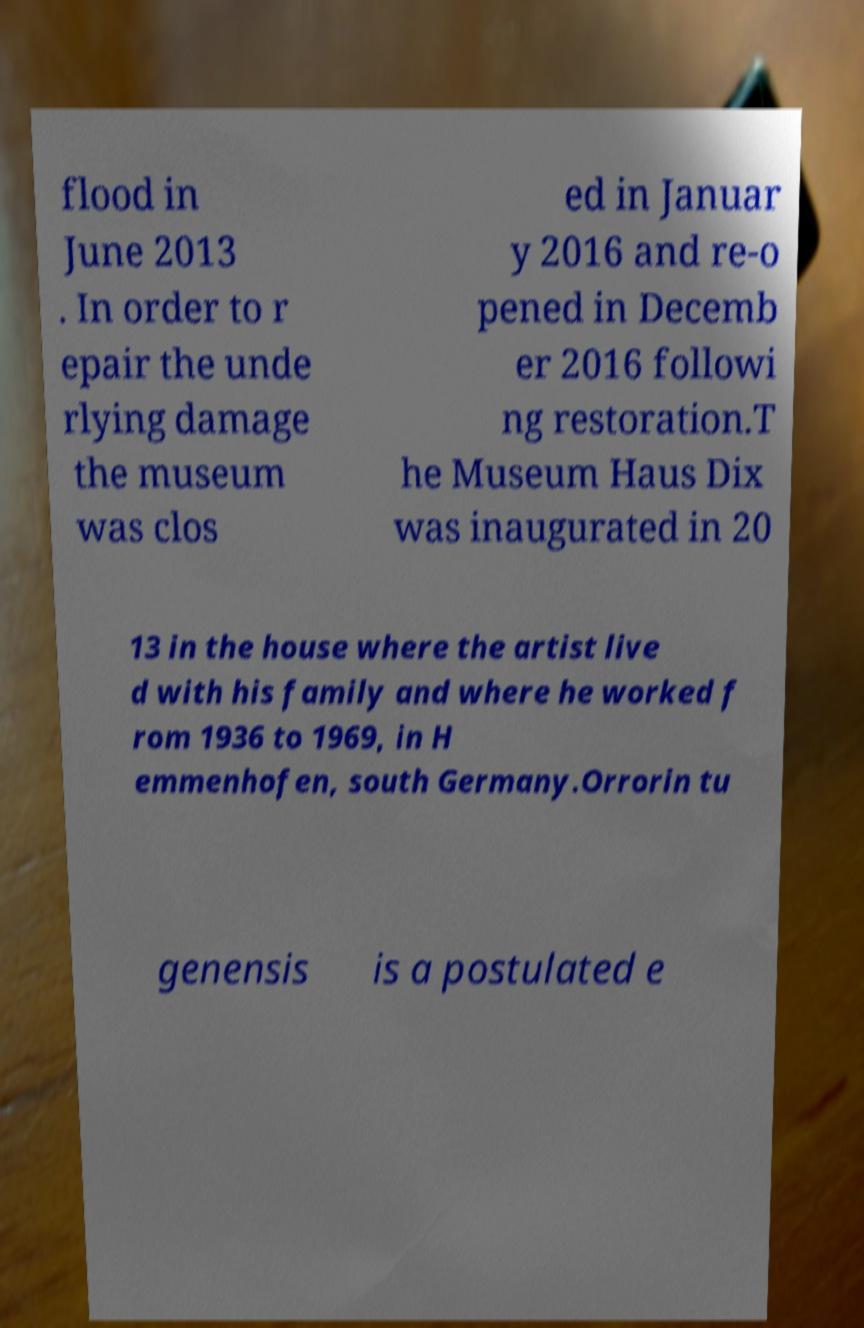Can you read and provide the text displayed in the image?This photo seems to have some interesting text. Can you extract and type it out for me? flood in June 2013 . In order to r epair the unde rlying damage the museum was clos ed in Januar y 2016 and re-o pened in Decemb er 2016 followi ng restoration.T he Museum Haus Dix was inaugurated in 20 13 in the house where the artist live d with his family and where he worked f rom 1936 to 1969, in H emmenhofen, south Germany.Orrorin tu genensis is a postulated e 